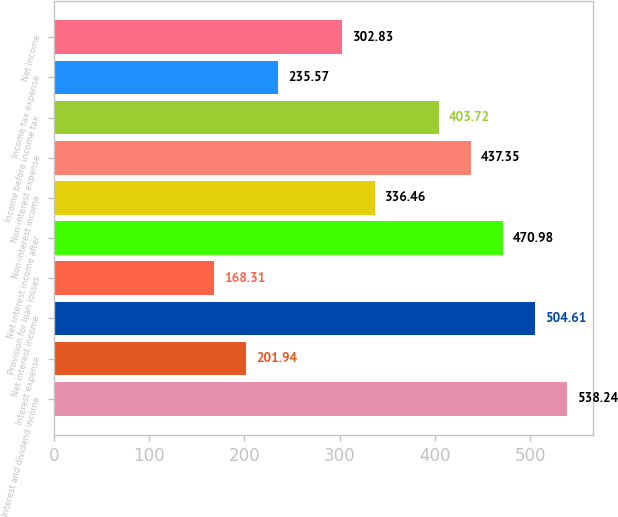Convert chart to OTSL. <chart><loc_0><loc_0><loc_500><loc_500><bar_chart><fcel>Interest and dividend income<fcel>Interest expense<fcel>Net interest income<fcel>Provision for loan losses<fcel>Net interest income after<fcel>Non-interest income<fcel>Non-interest expense<fcel>Income before income tax<fcel>Income tax expense<fcel>Net income<nl><fcel>538.24<fcel>201.94<fcel>504.61<fcel>168.31<fcel>470.98<fcel>336.46<fcel>437.35<fcel>403.72<fcel>235.57<fcel>302.83<nl></chart> 